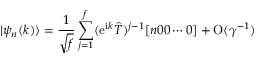Convert formula to latex. <formula><loc_0><loc_0><loc_500><loc_500>| \psi _ { n } ( k ) \rangle = { \frac { 1 } { \sqrt { f } } } \sum _ { j = 1 } ^ { f } ( e ^ { i k } \hat { T } ) ^ { j - 1 } [ n 0 0 \cdots 0 ] + O ( \gamma ^ { - 1 } )</formula> 